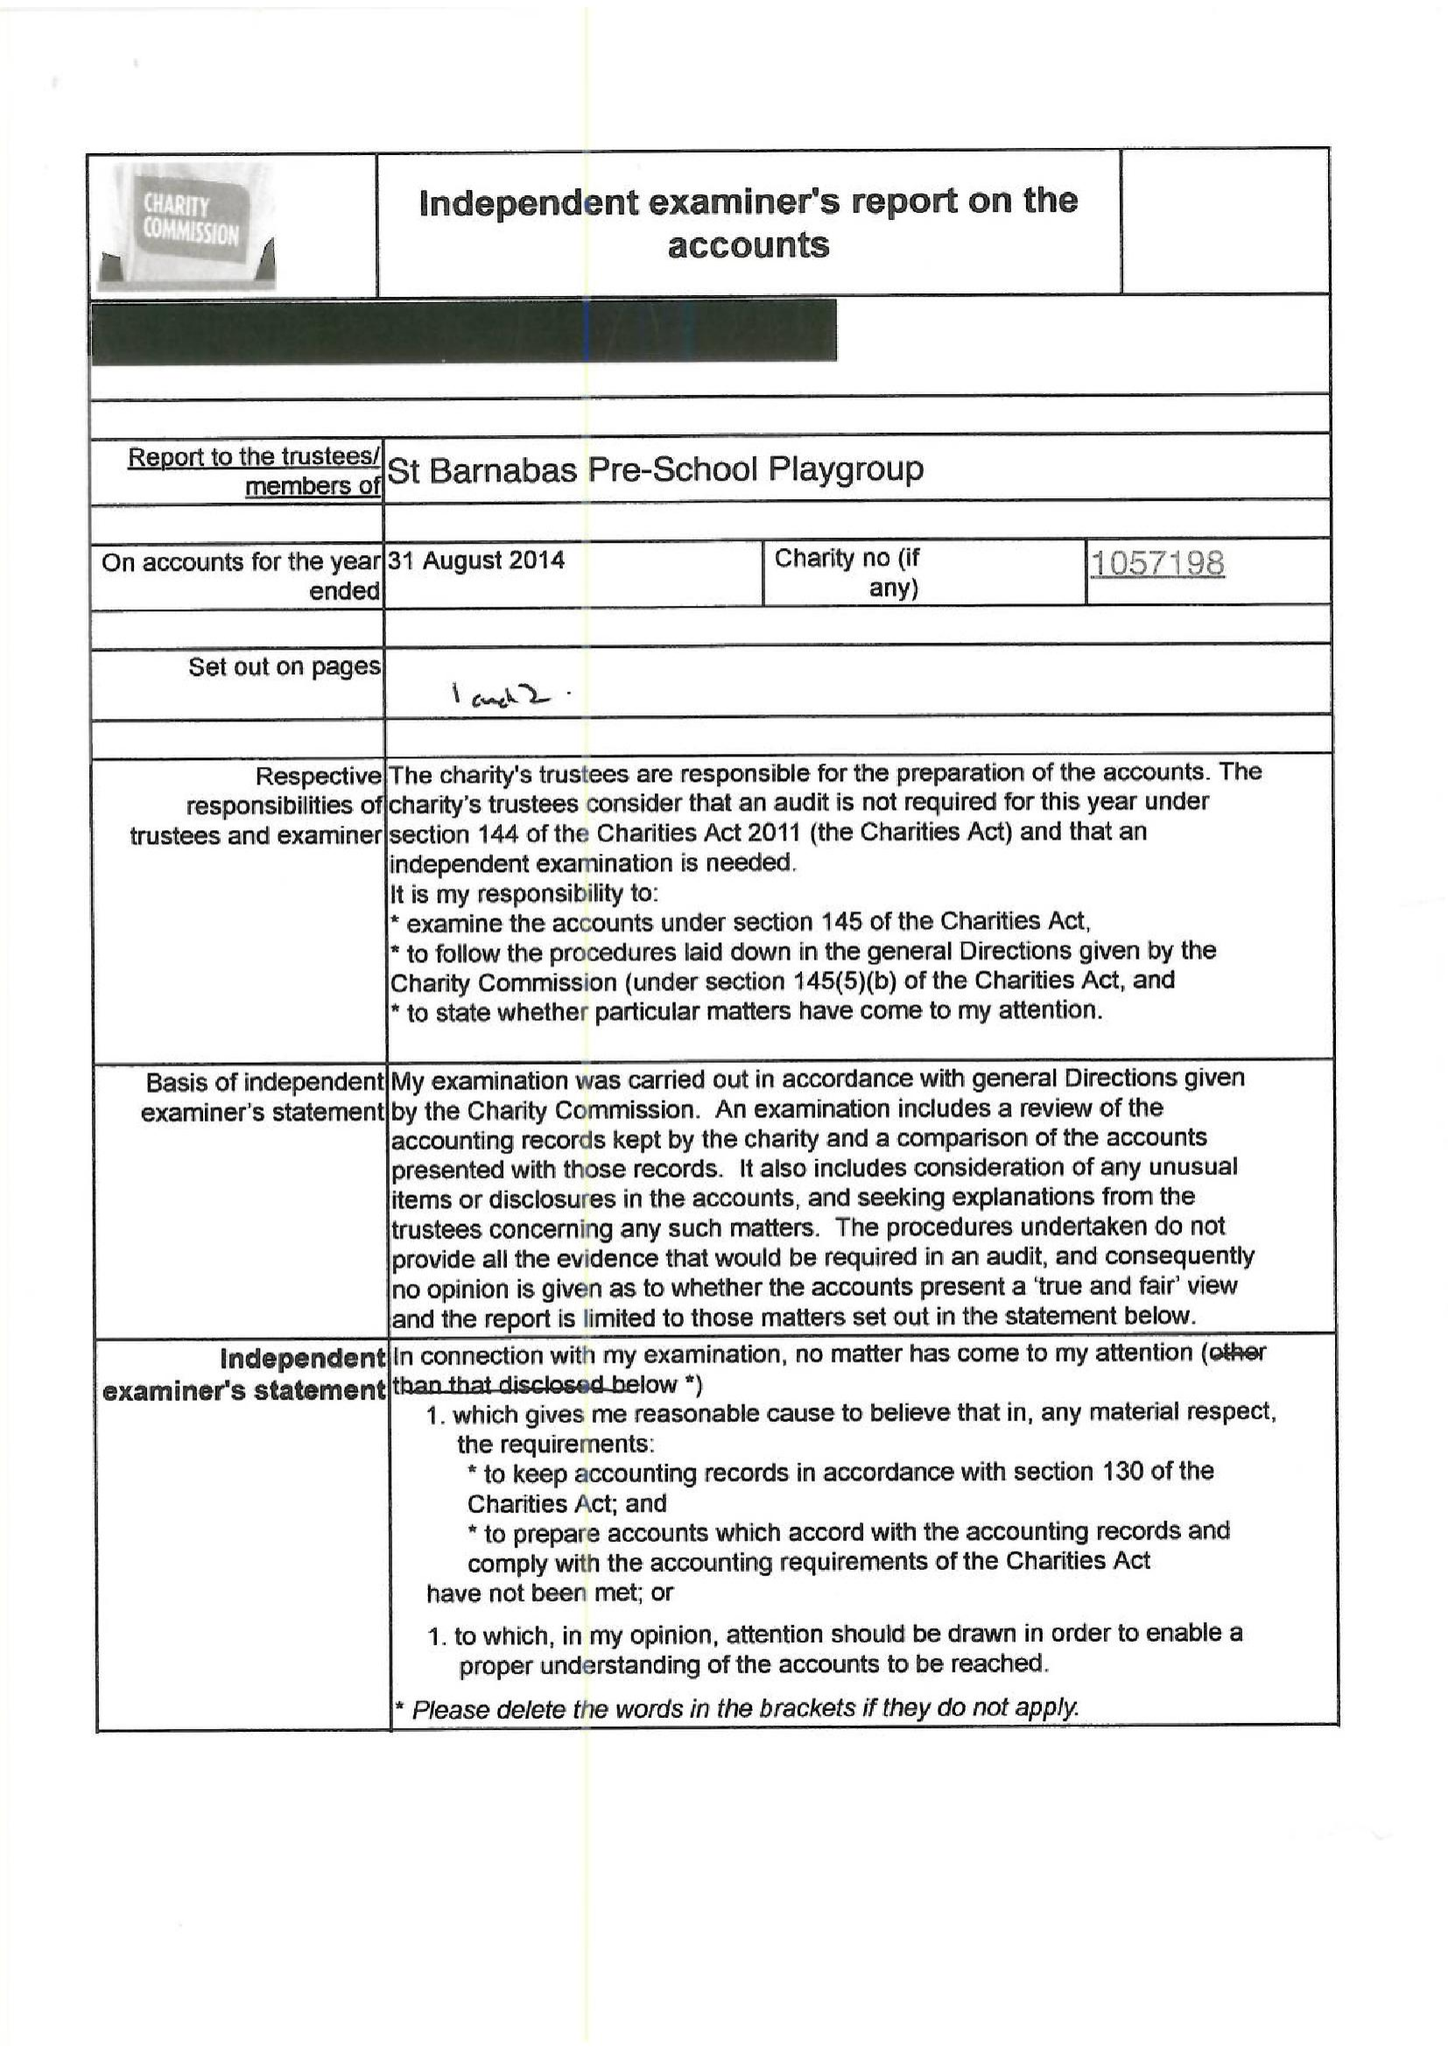What is the value for the address__postcode?
Answer the question using a single word or phrase. W5 1QG 